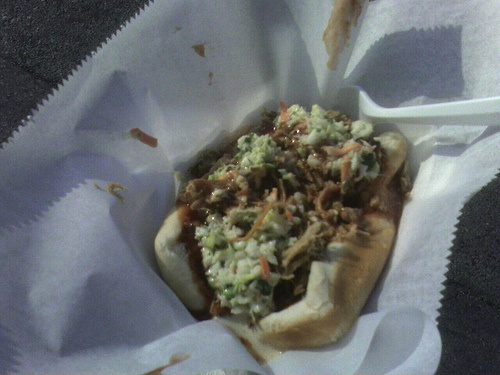Describe the objects in this image and their specific colors. I can see sandwich in black and gray tones and fork in black, darkgray, lightgray, and gray tones in this image. 